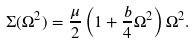Convert formula to latex. <formula><loc_0><loc_0><loc_500><loc_500>\Sigma ( \Omega ^ { 2 } ) = \frac { \mu } { 2 } \left ( 1 + \frac { b } { 4 } \Omega ^ { 2 } \right ) \Omega ^ { 2 } .</formula> 